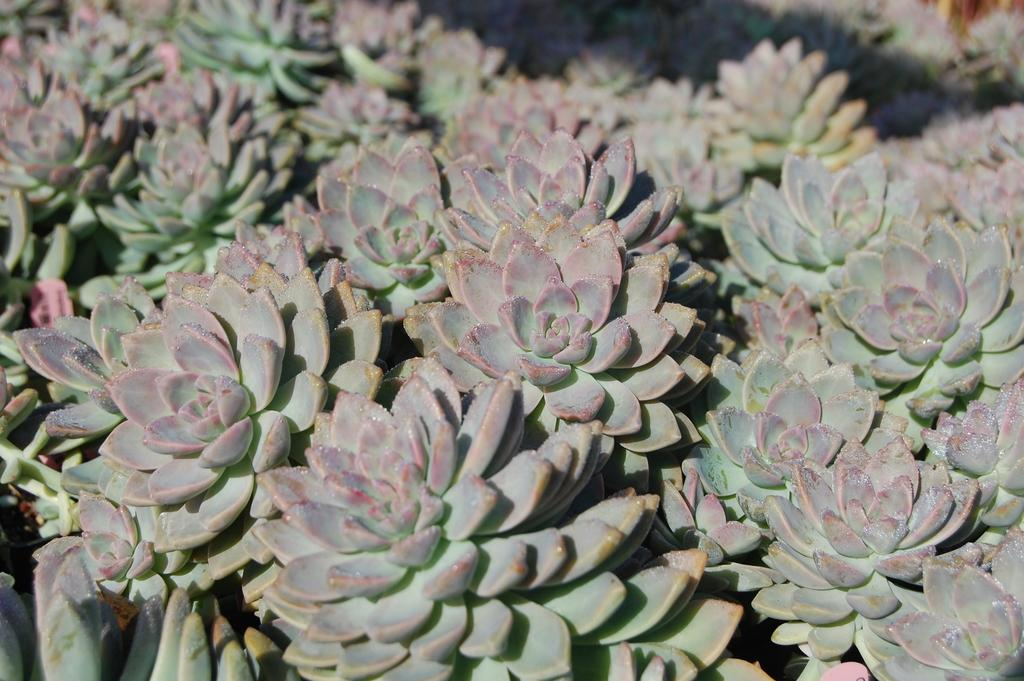What type of living organisms can be seen in the image? There are small plants in the image. How many houses are visible in the image? There are no houses present in the image; it only contains small plants. What type of spark can be seen in the image? There is no spark present in the image. 